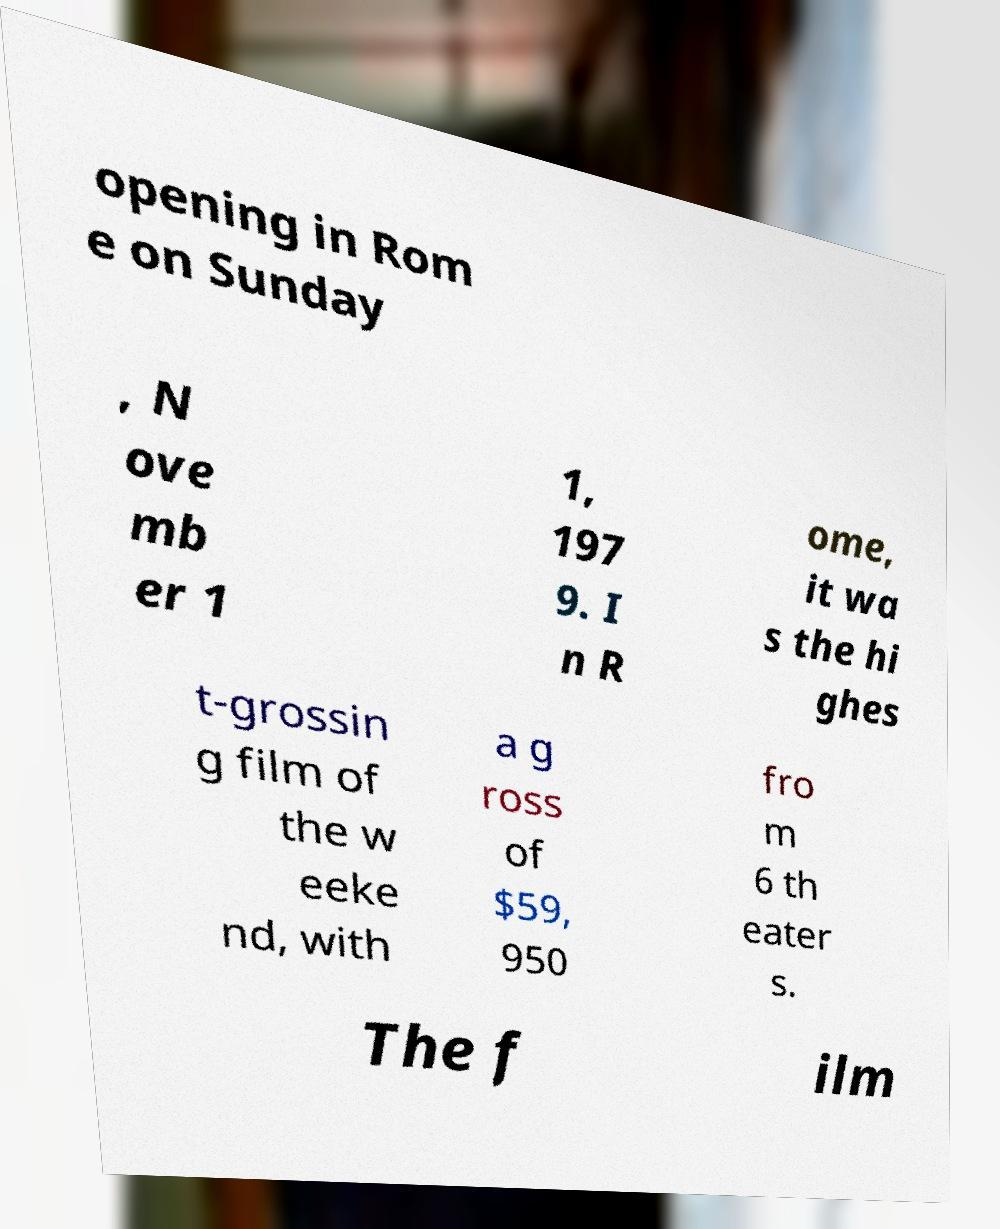There's text embedded in this image that I need extracted. Can you transcribe it verbatim? opening in Rom e on Sunday , N ove mb er 1 1, 197 9. I n R ome, it wa s the hi ghes t-grossin g film of the w eeke nd, with a g ross of $59, 950 fro m 6 th eater s. The f ilm 